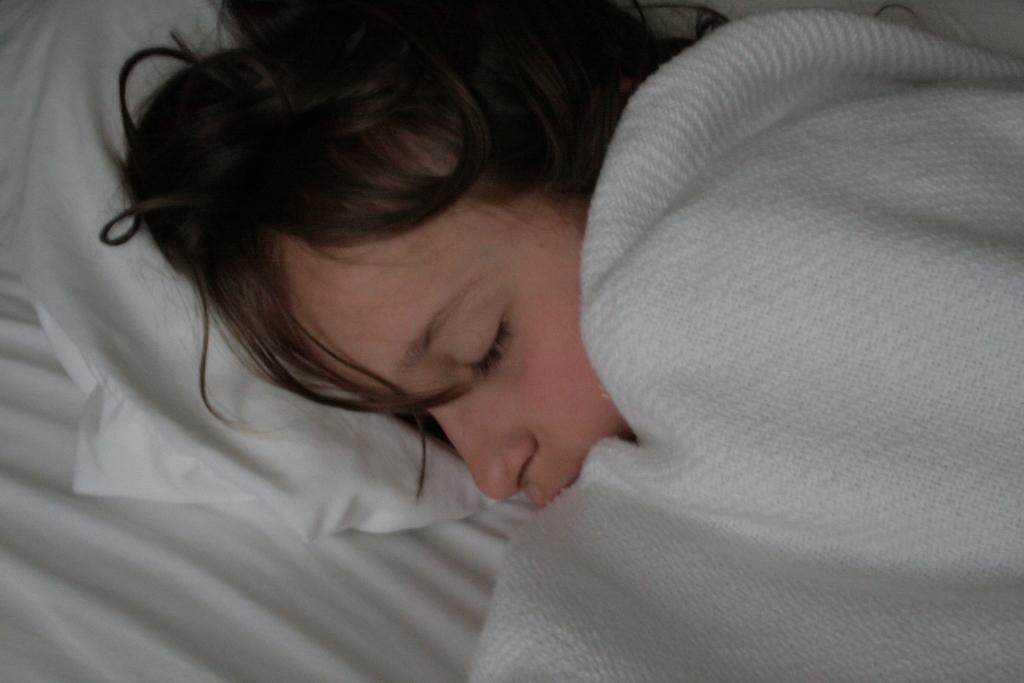Who is present in the image? There is a person in the image. What is the person doing in the image? The person is sleeping on a bed. What is the person using to cover themselves? The person is covering themselves with a blanket. What type of dock can be seen near the person in the image? There is no dock present in the image; it features a person sleeping on a bed with a blanket. 